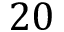Convert formula to latex. <formula><loc_0><loc_0><loc_500><loc_500>2 0</formula> 